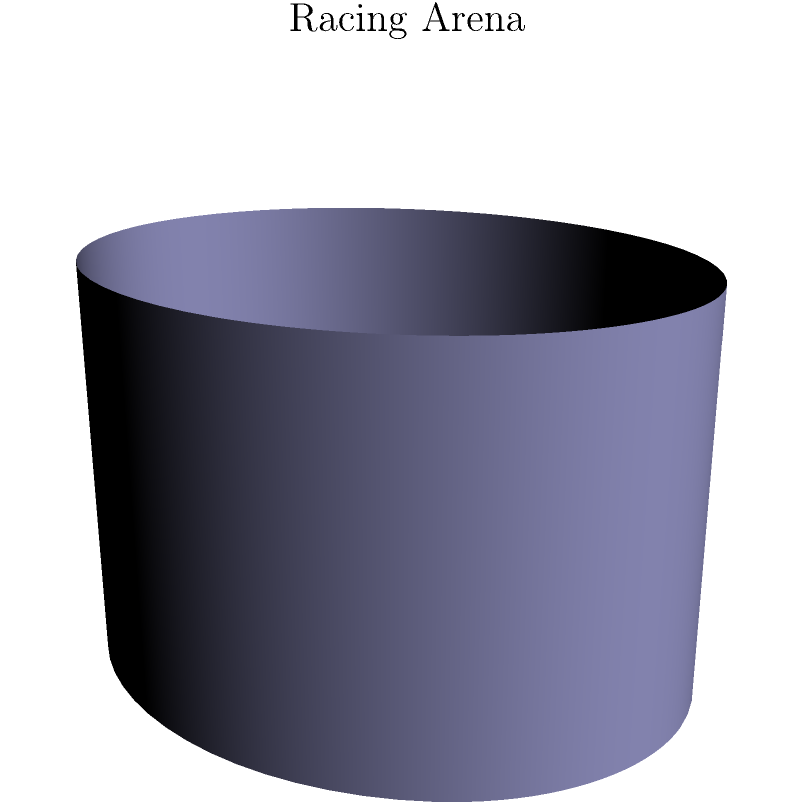You're designing a circular racing arena on the surface of a cylinder with a radius of 2 meters. If the arena has a radius of 1.5 meters when projected onto a flat surface, what is the actual area of the racing arena on the curved surface of the cylinder? Let's approach this step-by-step:

1) In Euclidean geometry, the area of a circle is given by $A = \pi r^2$. However, on a curved surface, this formula doesn't apply directly.

2) The surface we're dealing with is a cylinder. When we "unwrap" a cylinder, we get a rectangle. The width of this rectangle is the circumference of the cylinder's base, and the height is the height of the cylinder.

3) The circumference of the cylinder's base is $2\pi R$, where $R$ is the radius of the cylinder. Here, $R = 2$ meters.

4) On this "unwrapped" surface, our racing arena forms an ellipse, not a circle.

5) The width of this ellipse is the same as it would be on a flat surface: $2r = 2(1.5) = 3$ meters.

6) The height of the ellipse, however, is "stretched" to match the curvature of the cylinder. It forms an arc length on the cylinder's surface.

7) The arc length is given by $s = R\theta$, where $\theta$ is the central angle in radians. We can find $\theta$ using the formula: $\theta = \frac{r}{R} = \frac{1.5}{2} = 0.75$ radians.

8) So the height of our ellipse is $s = R\theta = 2(0.75) = 1.5$ meters.

9) The area of an ellipse is given by $A = \pi ab$, where $a$ and $b$ are the semi-major and semi-minor axes.

10) In our case, $a = 1.5$ and $b = 0.75$, so the area is:

    $A = \pi(1.5)(0.75) = 1.125\pi \approx 3.53$ square meters.
Answer: $1.125\pi$ square meters 